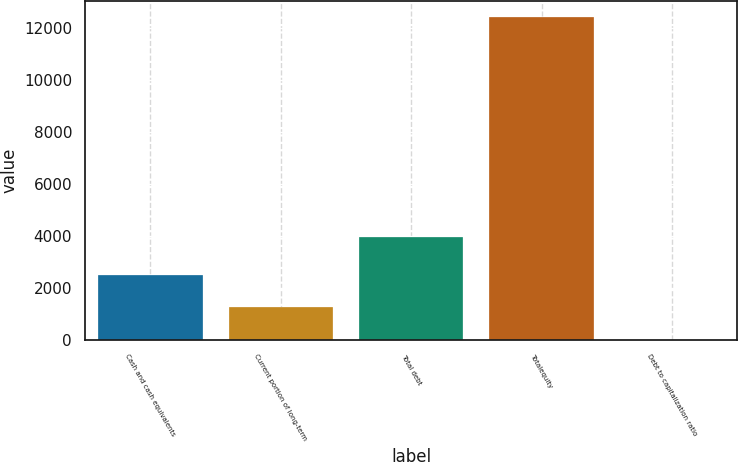Convert chart. <chart><loc_0><loc_0><loc_500><loc_500><bar_chart><fcel>Cash and cash equivalents<fcel>Current portion of long-term<fcel>Total debt<fcel>Totalequity<fcel>Debt to capitalization ratio<nl><fcel>2497.56<fcel>1260.88<fcel>3955<fcel>12391<fcel>24.2<nl></chart> 